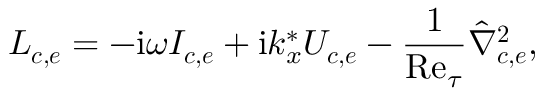Convert formula to latex. <formula><loc_0><loc_0><loc_500><loc_500>L _ { c , e } = - i \omega I _ { c , e } + i k _ { x } ^ { * } U _ { c , e } - \frac { 1 } { R e _ { \tau } } \hat { \nabla } _ { c , e } ^ { 2 } ,</formula> 